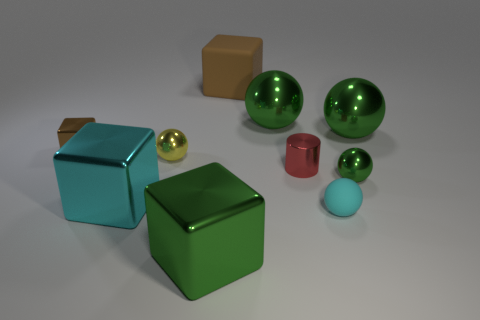Is there a thing of the same size as the red metal cylinder?
Your answer should be compact. Yes. Is the number of metal cylinders that are behind the large brown rubber object less than the number of large gray cylinders?
Your answer should be very brief. No. What material is the large green thing that is in front of the metallic cube behind the small metal ball that is to the right of the cyan rubber thing made of?
Make the answer very short. Metal. Are there more tiny rubber spheres on the right side of the big brown block than large brown matte things to the right of the green metallic block?
Make the answer very short. No. How many rubber objects are large brown objects or small red cylinders?
Keep it short and to the point. 1. What shape is the tiny shiny object that is the same color as the rubber cube?
Keep it short and to the point. Cube. What is the small sphere to the left of the brown matte cube made of?
Keep it short and to the point. Metal. How many objects are either big gray metal balls or tiny yellow shiny things that are behind the tiny metal cylinder?
Your response must be concise. 1. The cyan shiny object that is the same size as the brown matte cube is what shape?
Provide a short and direct response. Cube. What number of tiny blocks have the same color as the big rubber cube?
Offer a terse response. 1. 